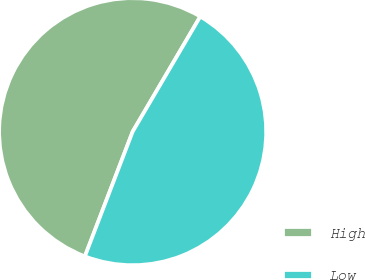Convert chart to OTSL. <chart><loc_0><loc_0><loc_500><loc_500><pie_chart><fcel>High<fcel>Low<nl><fcel>52.63%<fcel>47.37%<nl></chart> 